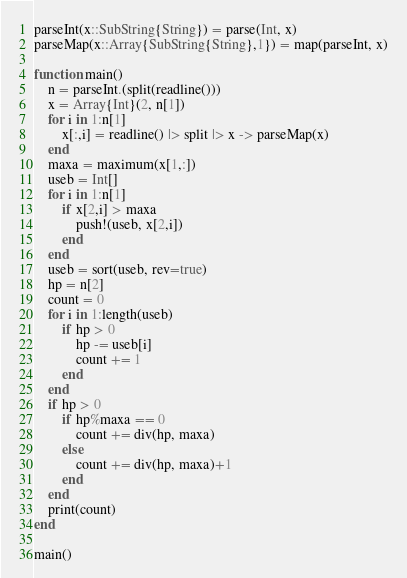Convert code to text. <code><loc_0><loc_0><loc_500><loc_500><_Julia_>parseInt(x::SubString{String}) = parse(Int, x)
parseMap(x::Array{SubString{String},1}) = map(parseInt, x)

function main()
	n = parseInt.(split(readline()))
	x = Array{Int}(2, n[1])
	for i in 1:n[1]
		x[:,i] = readline() |> split |> x -> parseMap(x)
	end
	maxa = maximum(x[1,:])
	useb = Int[]
	for i in 1:n[1]
		if x[2,i] > maxa
			push!(useb, x[2,i])
		end
	end
	useb = sort(useb, rev=true)
	hp = n[2]
	count = 0
	for i in 1:length(useb)
		if hp > 0
			hp -= useb[i]
			count += 1
		end
	end
	if hp > 0
		if hp%maxa == 0
			count += div(hp, maxa)
		else
			count += div(hp, maxa)+1
		end
	end
	print(count)
end

main()</code> 